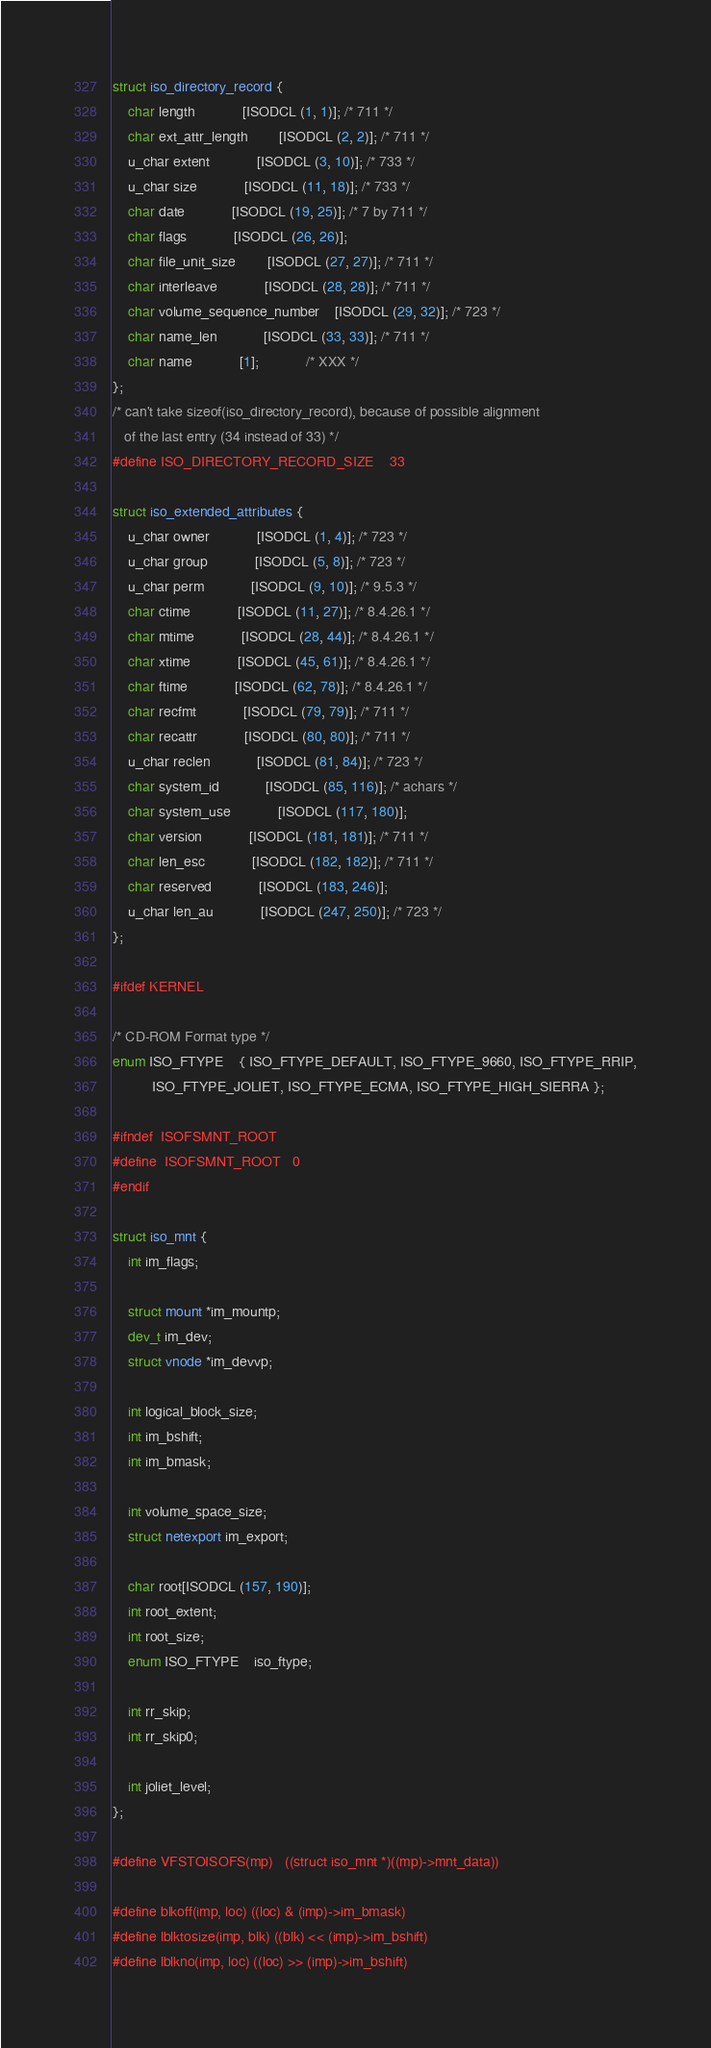<code> <loc_0><loc_0><loc_500><loc_500><_C_>struct iso_directory_record {
	char length			[ISODCL (1, 1)]; /* 711 */
	char ext_attr_length		[ISODCL (2, 2)]; /* 711 */
	u_char extent			[ISODCL (3, 10)]; /* 733 */
	u_char size			[ISODCL (11, 18)]; /* 733 */
	char date			[ISODCL (19, 25)]; /* 7 by 711 */
	char flags			[ISODCL (26, 26)];
	char file_unit_size		[ISODCL (27, 27)]; /* 711 */
	char interleave			[ISODCL (28, 28)]; /* 711 */
	char volume_sequence_number	[ISODCL (29, 32)]; /* 723 */
	char name_len			[ISODCL (33, 33)]; /* 711 */
	char name			[1];			/* XXX */
};
/* can't take sizeof(iso_directory_record), because of possible alignment
   of the last entry (34 instead of 33) */
#define ISO_DIRECTORY_RECORD_SIZE	33

struct iso_extended_attributes {
	u_char owner			[ISODCL (1, 4)]; /* 723 */
	u_char group			[ISODCL (5, 8)]; /* 723 */
	u_char perm			[ISODCL (9, 10)]; /* 9.5.3 */
	char ctime			[ISODCL (11, 27)]; /* 8.4.26.1 */
	char mtime			[ISODCL (28, 44)]; /* 8.4.26.1 */
	char xtime			[ISODCL (45, 61)]; /* 8.4.26.1 */
	char ftime			[ISODCL (62, 78)]; /* 8.4.26.1 */
	char recfmt			[ISODCL (79, 79)]; /* 711 */
	char recattr			[ISODCL (80, 80)]; /* 711 */
	u_char reclen			[ISODCL (81, 84)]; /* 723 */
	char system_id			[ISODCL (85, 116)]; /* achars */
	char system_use			[ISODCL (117, 180)];
	char version			[ISODCL (181, 181)]; /* 711 */
	char len_esc			[ISODCL (182, 182)]; /* 711 */
	char reserved			[ISODCL (183, 246)];
	u_char len_au			[ISODCL (247, 250)]; /* 723 */
};

#ifdef KERNEL

/* CD-ROM Format type */
enum ISO_FTYPE	{ ISO_FTYPE_DEFAULT, ISO_FTYPE_9660, ISO_FTYPE_RRIP,
		  ISO_FTYPE_JOLIET, ISO_FTYPE_ECMA, ISO_FTYPE_HIGH_SIERRA };

#ifndef	ISOFSMNT_ROOT
#define	ISOFSMNT_ROOT	0
#endif

struct iso_mnt {
	int im_flags;

	struct mount *im_mountp;
	dev_t im_dev;
	struct vnode *im_devvp;

	int logical_block_size;
	int im_bshift;
	int im_bmask;

	int volume_space_size;
	struct netexport im_export;

	char root[ISODCL (157, 190)];
	int root_extent;
	int root_size;
	enum ISO_FTYPE	iso_ftype;

	int rr_skip;
	int rr_skip0;

	int joliet_level;
};

#define VFSTOISOFS(mp)	((struct iso_mnt *)((mp)->mnt_data))

#define blkoff(imp, loc)	((loc) & (imp)->im_bmask)
#define lblktosize(imp, blk)	((blk) << (imp)->im_bshift)
#define lblkno(imp, loc)	((loc) >> (imp)->im_bshift)</code> 